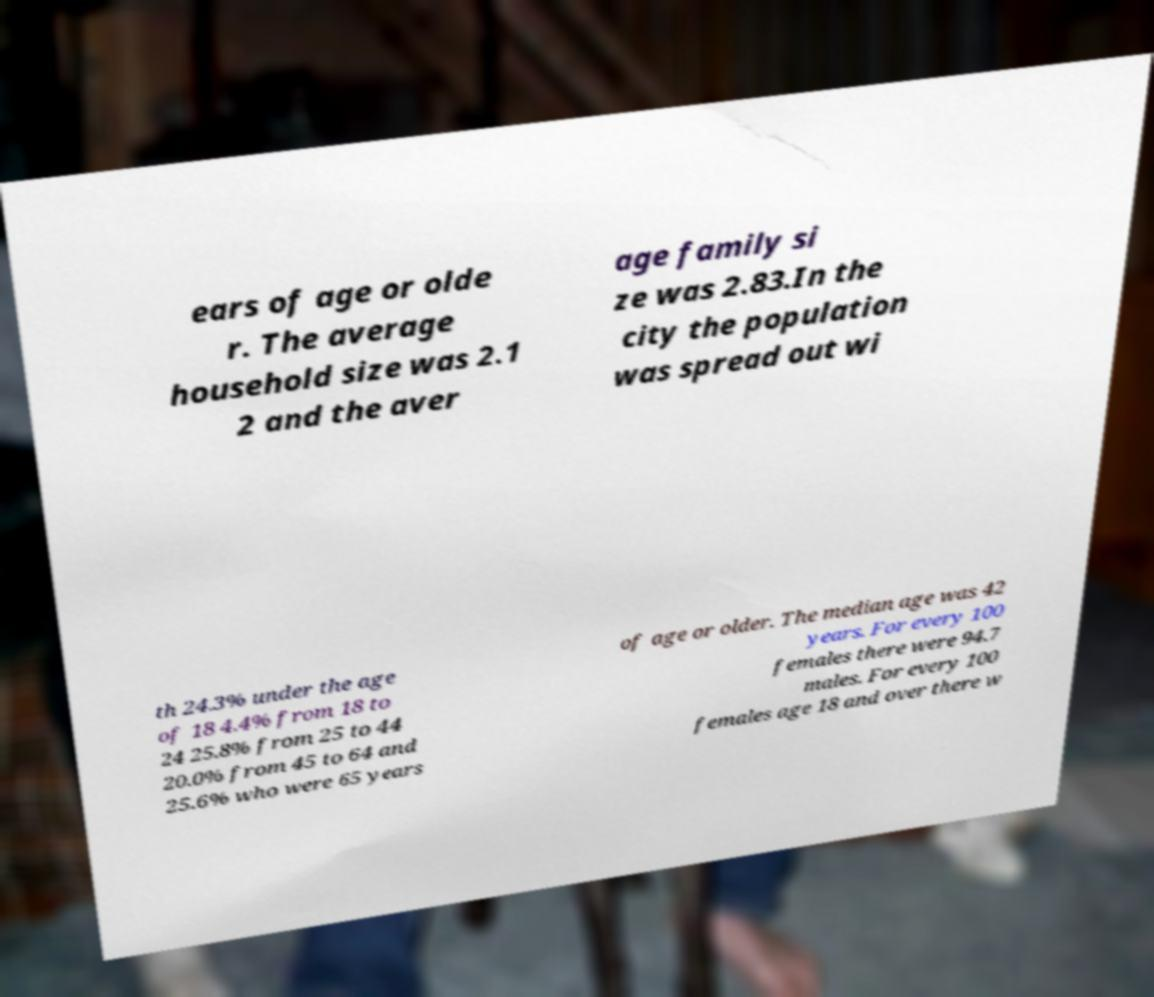There's text embedded in this image that I need extracted. Can you transcribe it verbatim? ears of age or olde r. The average household size was 2.1 2 and the aver age family si ze was 2.83.In the city the population was spread out wi th 24.3% under the age of 18 4.4% from 18 to 24 25.8% from 25 to 44 20.0% from 45 to 64 and 25.6% who were 65 years of age or older. The median age was 42 years. For every 100 females there were 94.7 males. For every 100 females age 18 and over there w 